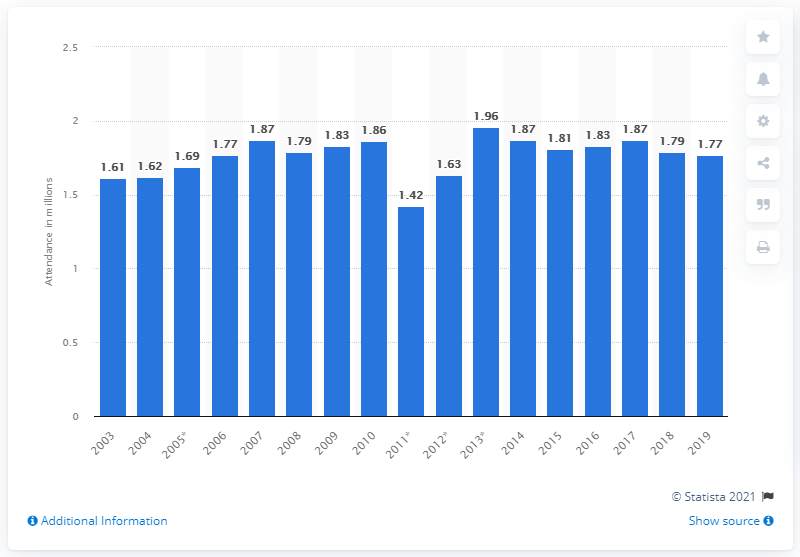Give some essential details in this illustration. In the 2019 Mountain West Conference season, a total of 1,770 spectators attended 76 games. 